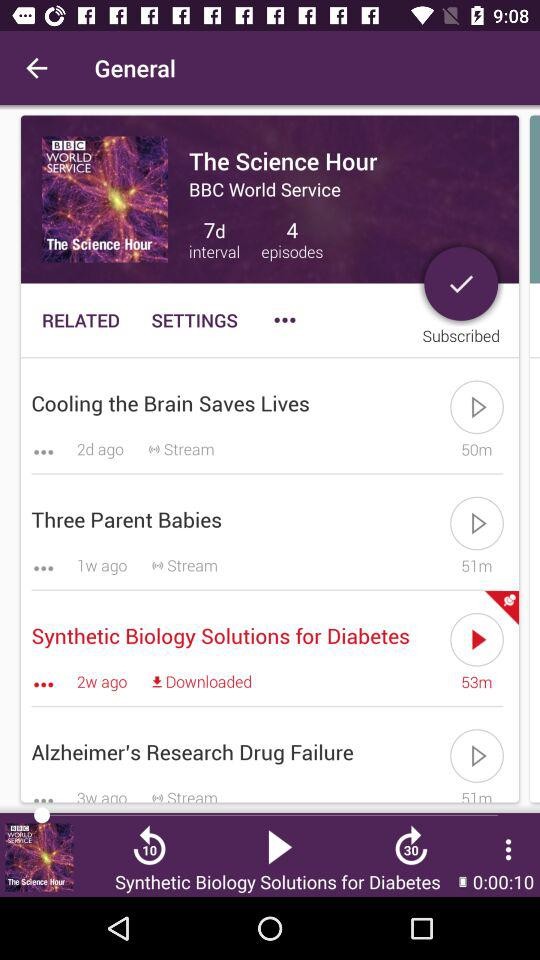What is the name of the currently playing episode? The currently playing episode is "Synthetic Biology Solutions for Diabetes". 